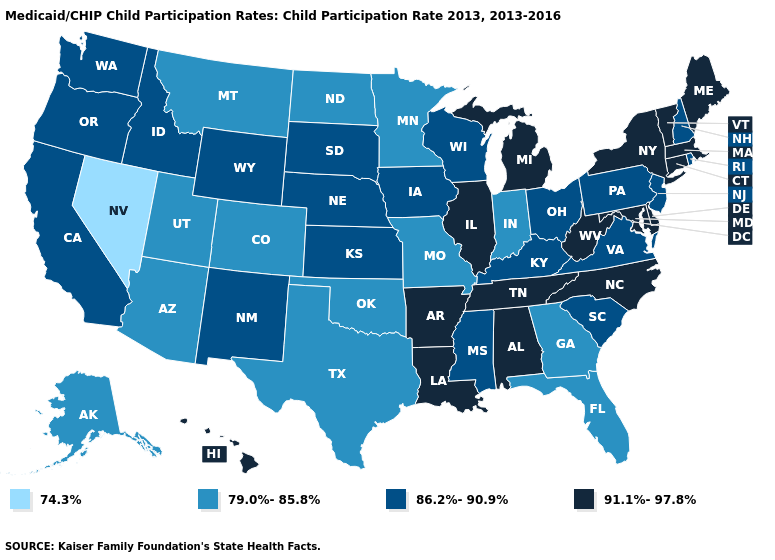What is the value of New York?
Give a very brief answer. 91.1%-97.8%. Name the states that have a value in the range 86.2%-90.9%?
Quick response, please. California, Idaho, Iowa, Kansas, Kentucky, Mississippi, Nebraska, New Hampshire, New Jersey, New Mexico, Ohio, Oregon, Pennsylvania, Rhode Island, South Carolina, South Dakota, Virginia, Washington, Wisconsin, Wyoming. What is the highest value in the USA?
Concise answer only. 91.1%-97.8%. Name the states that have a value in the range 86.2%-90.9%?
Keep it brief. California, Idaho, Iowa, Kansas, Kentucky, Mississippi, Nebraska, New Hampshire, New Jersey, New Mexico, Ohio, Oregon, Pennsylvania, Rhode Island, South Carolina, South Dakota, Virginia, Washington, Wisconsin, Wyoming. Name the states that have a value in the range 79.0%-85.8%?
Answer briefly. Alaska, Arizona, Colorado, Florida, Georgia, Indiana, Minnesota, Missouri, Montana, North Dakota, Oklahoma, Texas, Utah. Which states have the lowest value in the Northeast?
Write a very short answer. New Hampshire, New Jersey, Pennsylvania, Rhode Island. Name the states that have a value in the range 91.1%-97.8%?
Be succinct. Alabama, Arkansas, Connecticut, Delaware, Hawaii, Illinois, Louisiana, Maine, Maryland, Massachusetts, Michigan, New York, North Carolina, Tennessee, Vermont, West Virginia. What is the highest value in the MidWest ?
Keep it brief. 91.1%-97.8%. Does Hawaii have the lowest value in the USA?
Concise answer only. No. What is the value of South Carolina?
Keep it brief. 86.2%-90.9%. Does Washington have a higher value than West Virginia?
Write a very short answer. No. What is the value of Vermont?
Be succinct. 91.1%-97.8%. What is the highest value in the South ?
Quick response, please. 91.1%-97.8%. Does Rhode Island have a higher value than Florida?
Keep it brief. Yes. Among the states that border North Dakota , which have the lowest value?
Write a very short answer. Minnesota, Montana. 